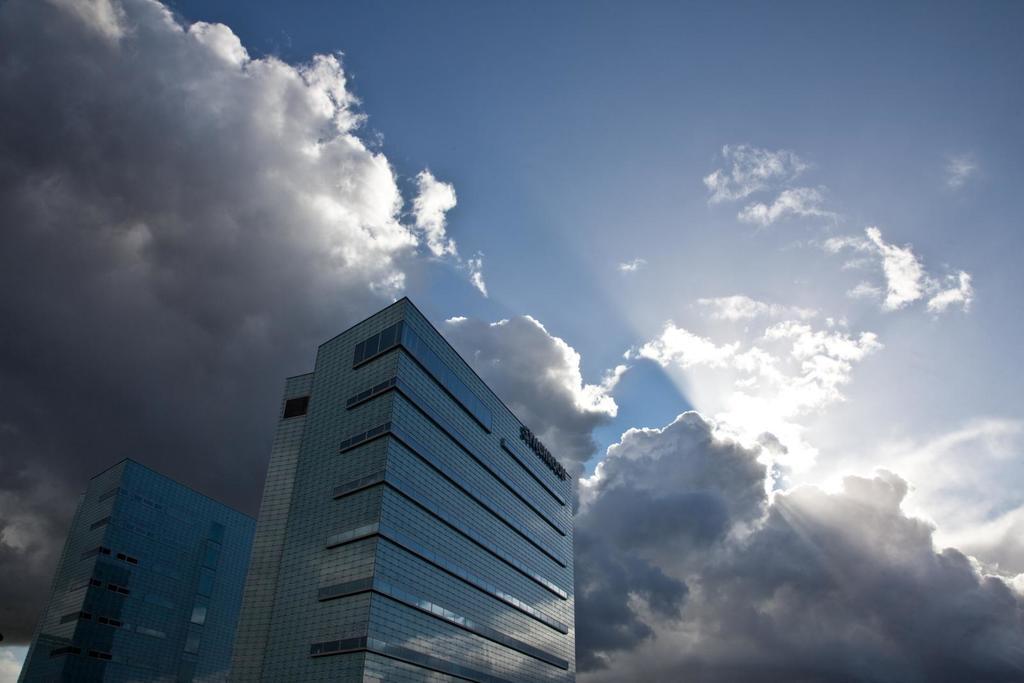Could you give a brief overview of what you see in this image? In this image we can see buildings, at above the sky is cloudy. 